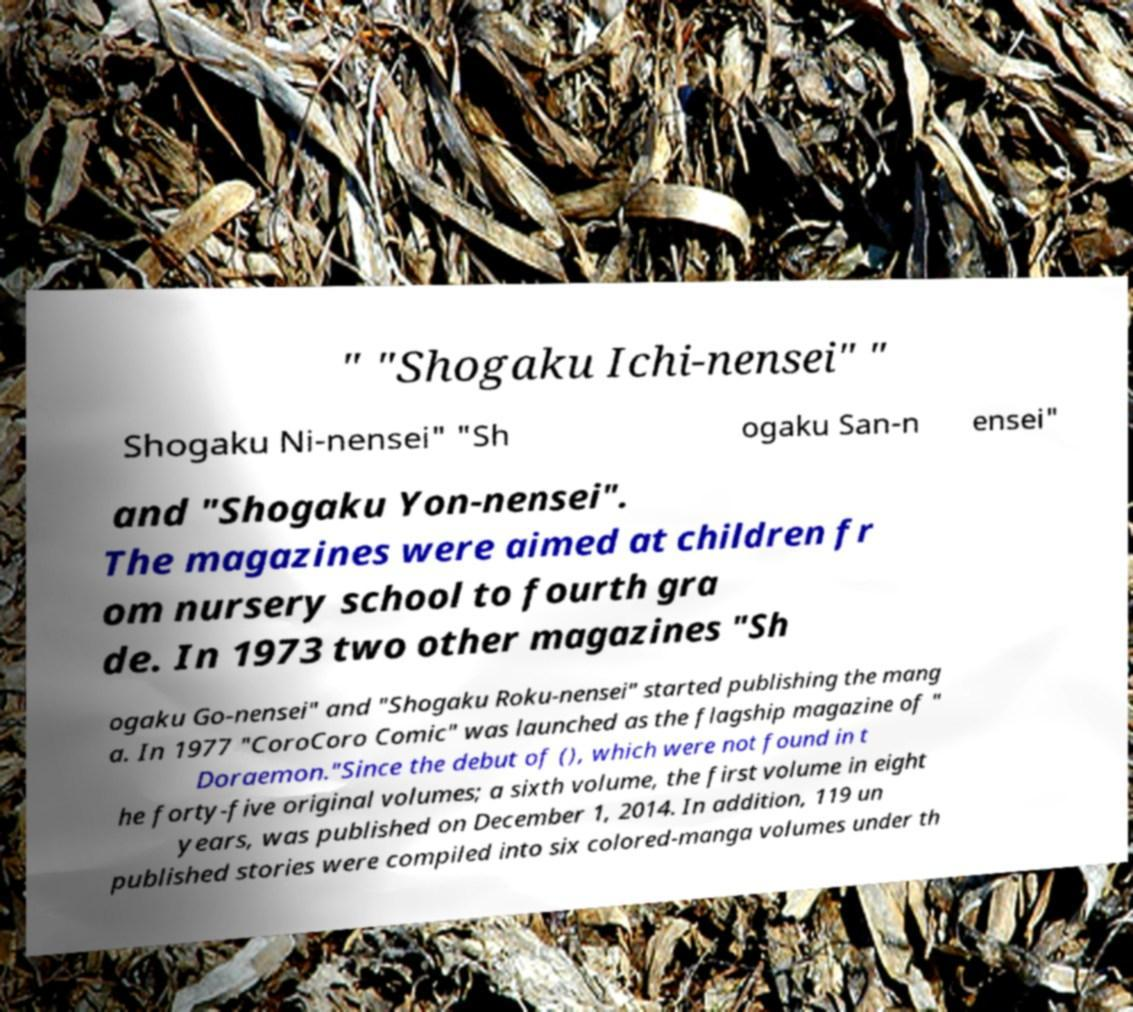Can you accurately transcribe the text from the provided image for me? " "Shogaku Ichi-nensei" " Shogaku Ni-nensei" "Sh ogaku San-n ensei" and "Shogaku Yon-nensei". The magazines were aimed at children fr om nursery school to fourth gra de. In 1973 two other magazines "Sh ogaku Go-nensei" and "Shogaku Roku-nensei" started publishing the mang a. In 1977 "CoroCoro Comic" was launched as the flagship magazine of " Doraemon."Since the debut of (), which were not found in t he forty-five original volumes; a sixth volume, the first volume in eight years, was published on December 1, 2014. In addition, 119 un published stories were compiled into six colored-manga volumes under th 